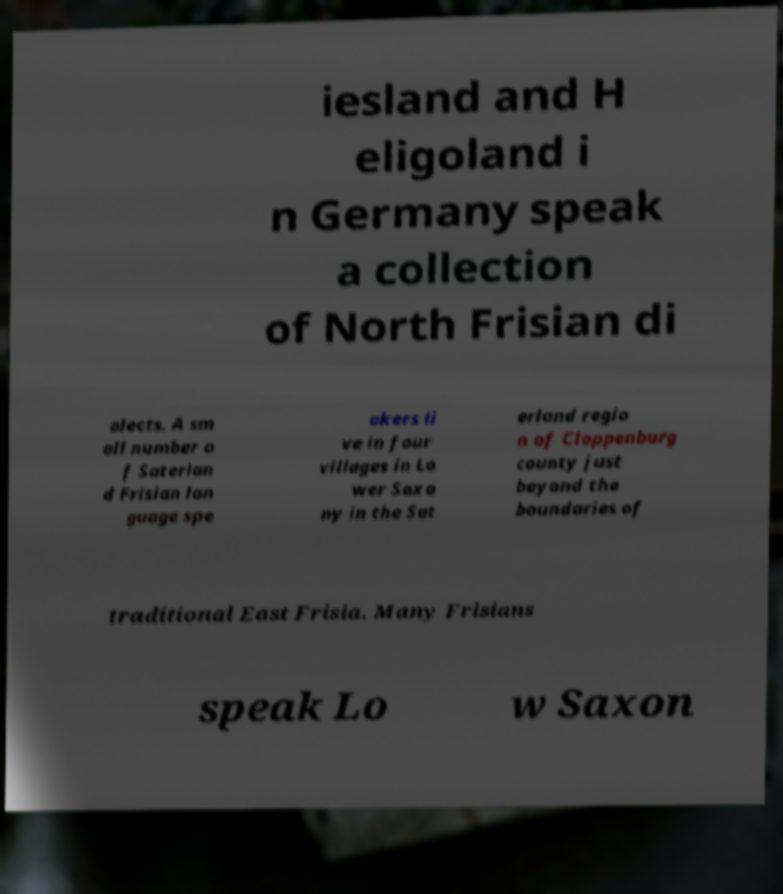What messages or text are displayed in this image? I need them in a readable, typed format. iesland and H eligoland i n Germany speak a collection of North Frisian di alects. A sm all number o f Saterlan d Frisian lan guage spe akers li ve in four villages in Lo wer Saxo ny in the Sat erland regio n of Cloppenburg county just beyond the boundaries of traditional East Frisia. Many Frisians speak Lo w Saxon 